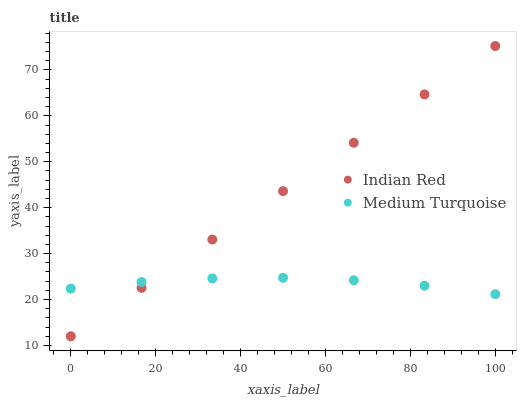Does Medium Turquoise have the minimum area under the curve?
Answer yes or no. Yes. Does Indian Red have the maximum area under the curve?
Answer yes or no. Yes. Does Indian Red have the minimum area under the curve?
Answer yes or no. No. Is Indian Red the smoothest?
Answer yes or no. Yes. Is Medium Turquoise the roughest?
Answer yes or no. Yes. Is Indian Red the roughest?
Answer yes or no. No. Does Indian Red have the lowest value?
Answer yes or no. Yes. Does Indian Red have the highest value?
Answer yes or no. Yes. Does Indian Red intersect Medium Turquoise?
Answer yes or no. Yes. Is Indian Red less than Medium Turquoise?
Answer yes or no. No. Is Indian Red greater than Medium Turquoise?
Answer yes or no. No. 